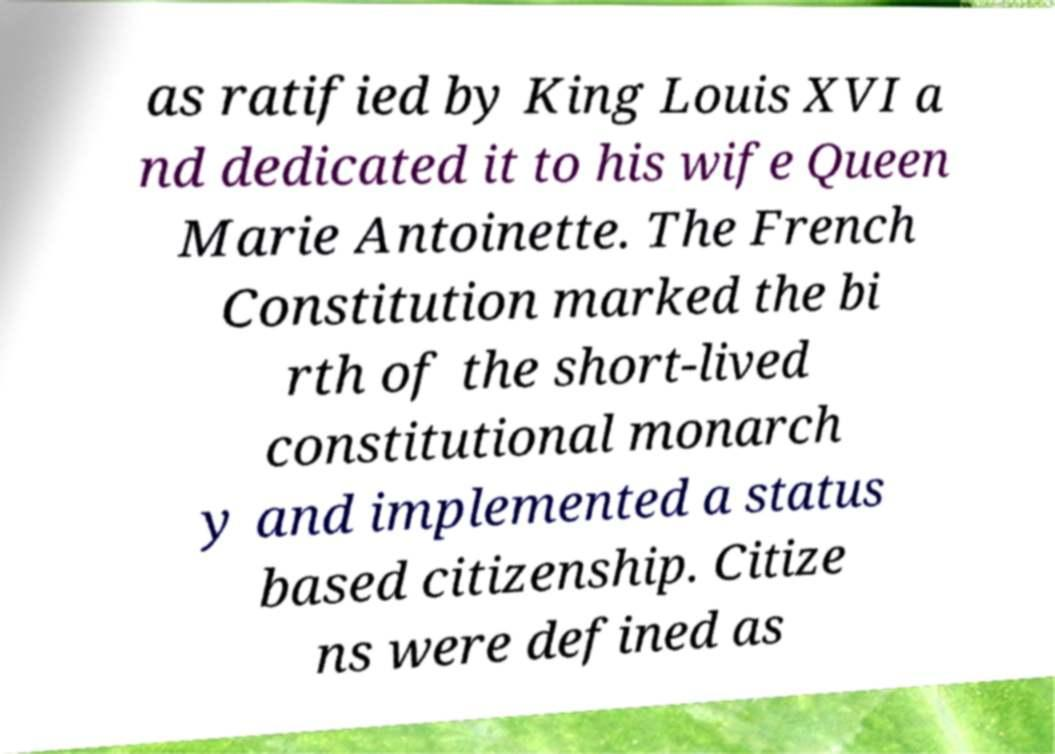Can you accurately transcribe the text from the provided image for me? as ratified by King Louis XVI a nd dedicated it to his wife Queen Marie Antoinette. The French Constitution marked the bi rth of the short-lived constitutional monarch y and implemented a status based citizenship. Citize ns were defined as 